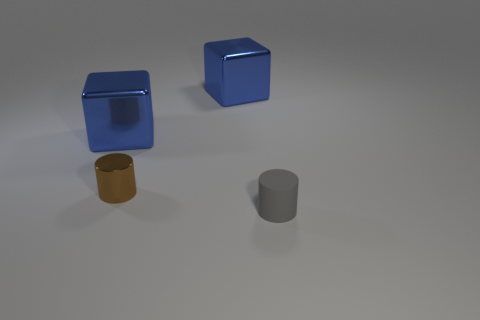There is a brown thing; does it have the same shape as the blue thing to the right of the metal cylinder?
Your answer should be compact. No. There is a blue metal object behind the blue metallic object on the left side of the cylinder that is behind the matte cylinder; what shape is it?
Keep it short and to the point. Cube. How many other objects are the same material as the small gray thing?
Provide a short and direct response. 0. How many objects are either small cylinders to the left of the tiny gray matte thing or yellow matte cylinders?
Offer a terse response. 1. What is the shape of the tiny thing left of the small object to the right of the small brown thing?
Give a very brief answer. Cylinder. Does the tiny thing that is behind the small gray matte cylinder have the same shape as the gray matte thing?
Provide a succinct answer. Yes. There is a small thing behind the small rubber cylinder; what color is it?
Ensure brevity in your answer.  Brown. What number of cylinders are small metallic objects or matte things?
Your response must be concise. 2. There is a cylinder that is left of the blue metallic object that is right of the small brown metallic cylinder; what size is it?
Your response must be concise. Small. There is a tiny metal cylinder; how many objects are to the right of it?
Offer a very short reply. 2. 